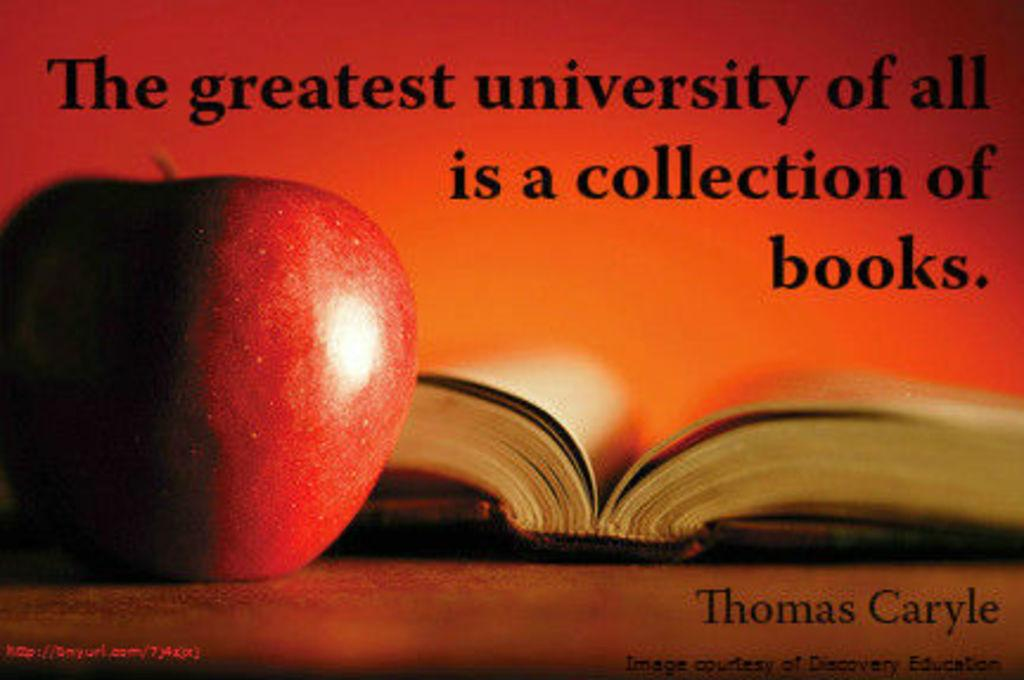<image>
Render a clear and concise summary of the photo. An apple next to a book and the words "The greatest university of all is a collection of books". 